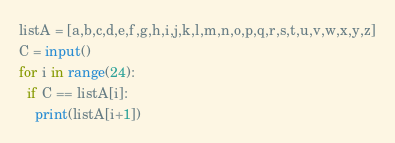<code> <loc_0><loc_0><loc_500><loc_500><_Python_>listA = [a,b,c,d,e,f,g,h,i,j,k,l,m,n,o,p,q,r,s,t,u,v,w,x,y,z]
C = input()
for i in range(24):
  if C == listA[i]:
    print(listA[i+1])</code> 